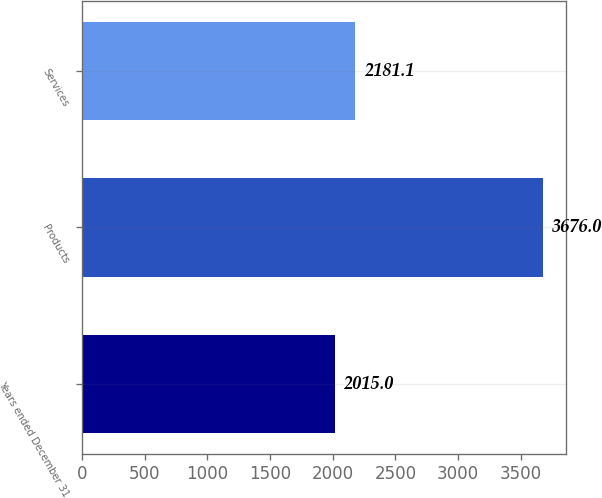<chart> <loc_0><loc_0><loc_500><loc_500><bar_chart><fcel>Years ended December 31<fcel>Products<fcel>Services<nl><fcel>2015<fcel>3676<fcel>2181.1<nl></chart> 